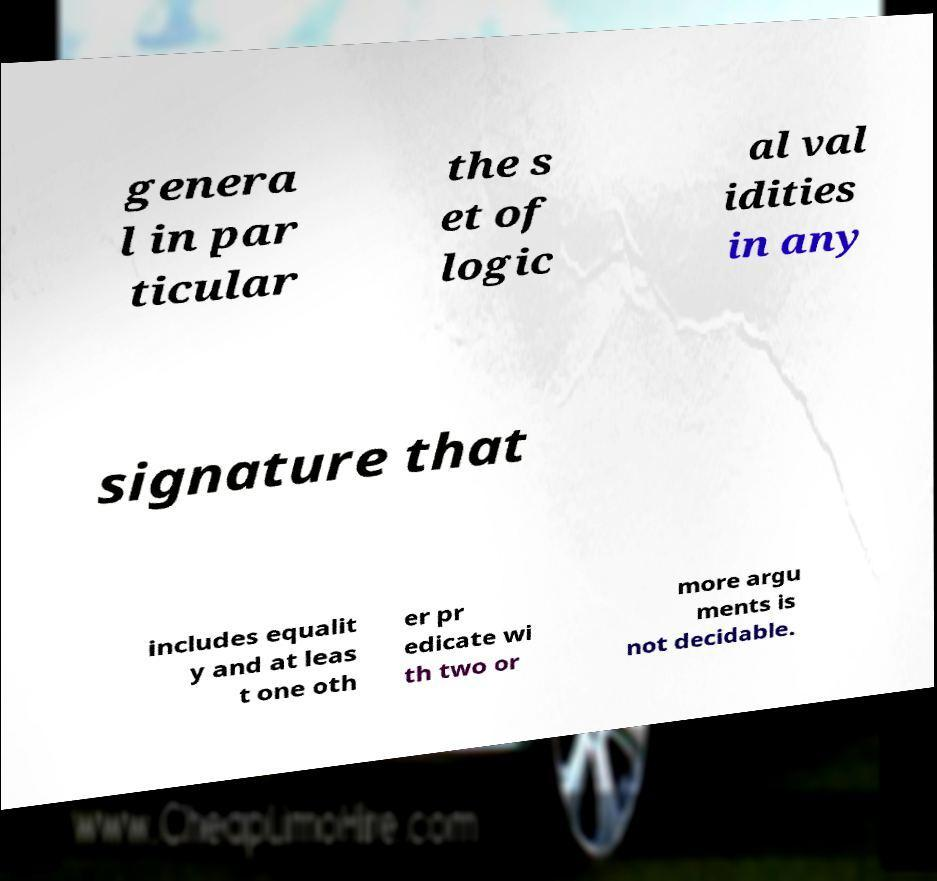Please read and relay the text visible in this image. What does it say? genera l in par ticular the s et of logic al val idities in any signature that includes equalit y and at leas t one oth er pr edicate wi th two or more argu ments is not decidable. 